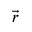<formula> <loc_0><loc_0><loc_500><loc_500>\vec { r }</formula> 